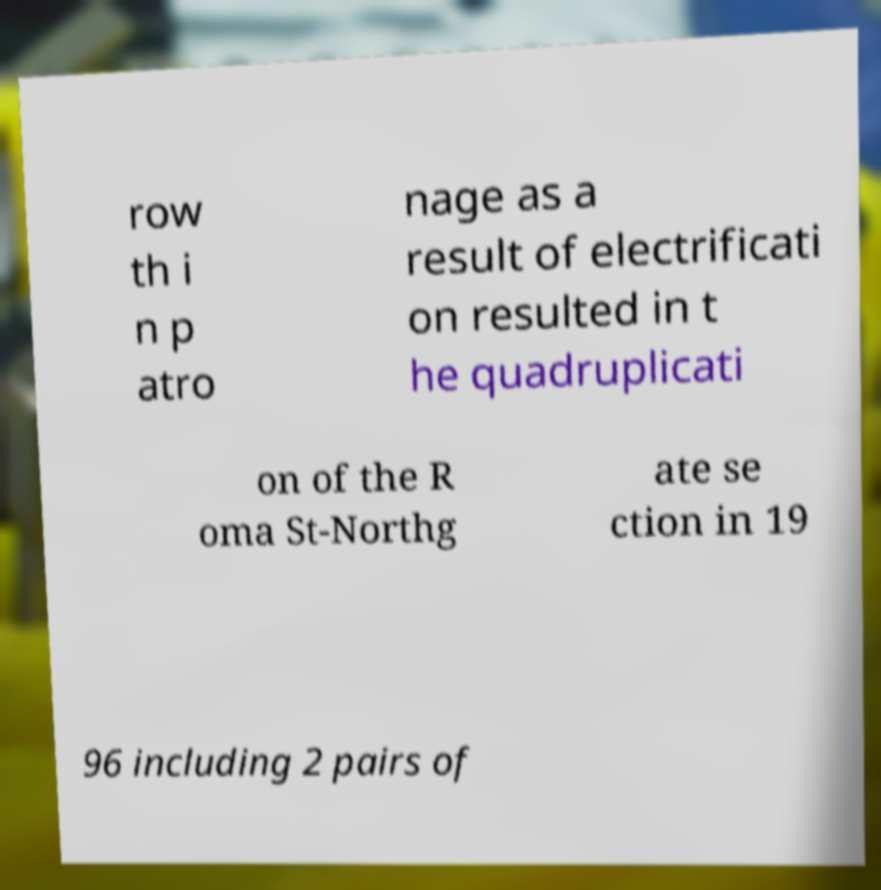Please read and relay the text visible in this image. What does it say? row th i n p atro nage as a result of electrificati on resulted in t he quadruplicati on of the R oma St-Northg ate se ction in 19 96 including 2 pairs of 